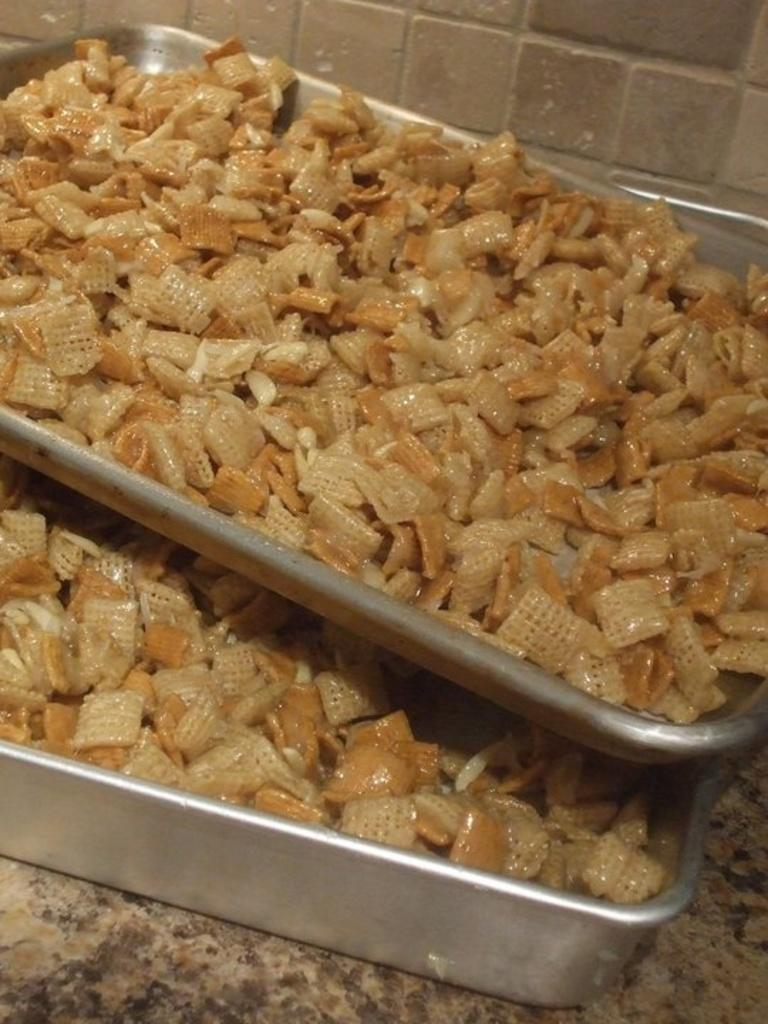What is located in the center of the image? There are food items in a tray in the center of the image. What can be seen in the background of the image? There is a wall in the background of the image. What is visible at the bottom of the image? There is a floor visible at the bottom of the image. Where is the brain located in the image? There is no brain present in the image. What type of basket is visible in the image? There is no basket present in the image. 